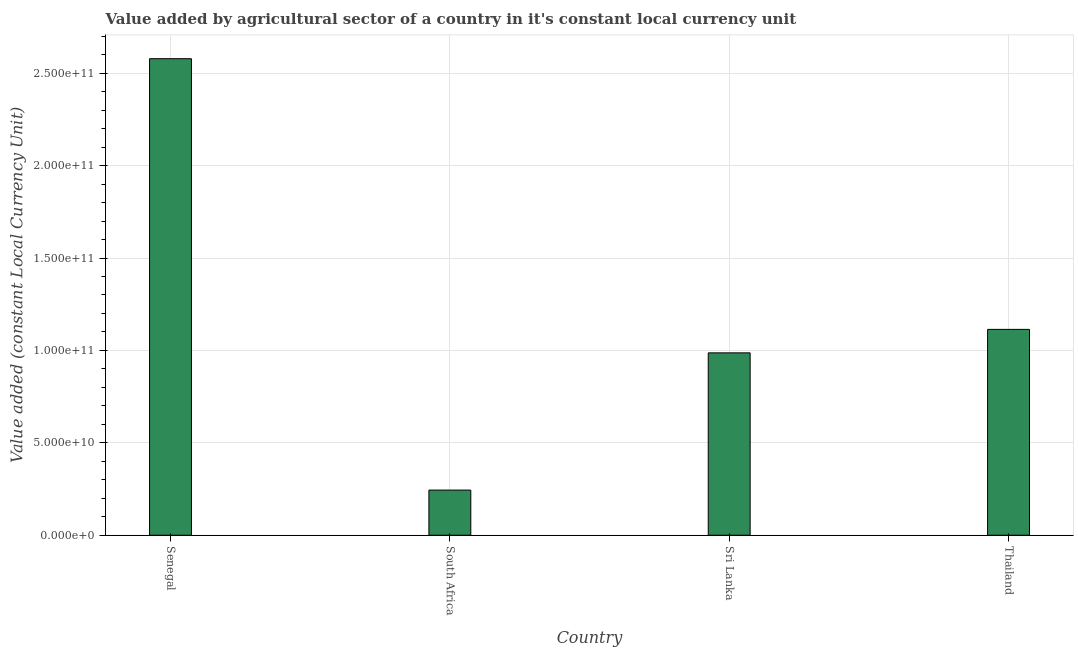Does the graph contain any zero values?
Provide a short and direct response. No. Does the graph contain grids?
Keep it short and to the point. Yes. What is the title of the graph?
Ensure brevity in your answer.  Value added by agricultural sector of a country in it's constant local currency unit. What is the label or title of the X-axis?
Your response must be concise. Country. What is the label or title of the Y-axis?
Give a very brief answer. Value added (constant Local Currency Unit). What is the value added by agriculture sector in Senegal?
Your answer should be compact. 2.58e+11. Across all countries, what is the maximum value added by agriculture sector?
Make the answer very short. 2.58e+11. Across all countries, what is the minimum value added by agriculture sector?
Ensure brevity in your answer.  2.44e+1. In which country was the value added by agriculture sector maximum?
Give a very brief answer. Senegal. In which country was the value added by agriculture sector minimum?
Give a very brief answer. South Africa. What is the sum of the value added by agriculture sector?
Give a very brief answer. 4.92e+11. What is the difference between the value added by agriculture sector in Senegal and Sri Lanka?
Your answer should be compact. 1.59e+11. What is the average value added by agriculture sector per country?
Your response must be concise. 1.23e+11. What is the median value added by agriculture sector?
Give a very brief answer. 1.05e+11. In how many countries, is the value added by agriculture sector greater than 10000000000 LCU?
Offer a very short reply. 4. What is the ratio of the value added by agriculture sector in Senegal to that in Thailand?
Make the answer very short. 2.31. Is the value added by agriculture sector in Senegal less than that in Thailand?
Give a very brief answer. No. What is the difference between the highest and the second highest value added by agriculture sector?
Offer a terse response. 1.46e+11. What is the difference between the highest and the lowest value added by agriculture sector?
Your answer should be very brief. 2.33e+11. In how many countries, is the value added by agriculture sector greater than the average value added by agriculture sector taken over all countries?
Make the answer very short. 1. Are all the bars in the graph horizontal?
Offer a terse response. No. Are the values on the major ticks of Y-axis written in scientific E-notation?
Offer a terse response. Yes. What is the Value added (constant Local Currency Unit) in Senegal?
Provide a succinct answer. 2.58e+11. What is the Value added (constant Local Currency Unit) in South Africa?
Your answer should be compact. 2.44e+1. What is the Value added (constant Local Currency Unit) of Sri Lanka?
Your answer should be very brief. 9.87e+1. What is the Value added (constant Local Currency Unit) in Thailand?
Your answer should be compact. 1.11e+11. What is the difference between the Value added (constant Local Currency Unit) in Senegal and South Africa?
Make the answer very short. 2.33e+11. What is the difference between the Value added (constant Local Currency Unit) in Senegal and Sri Lanka?
Make the answer very short. 1.59e+11. What is the difference between the Value added (constant Local Currency Unit) in Senegal and Thailand?
Make the answer very short. 1.46e+11. What is the difference between the Value added (constant Local Currency Unit) in South Africa and Sri Lanka?
Keep it short and to the point. -7.43e+1. What is the difference between the Value added (constant Local Currency Unit) in South Africa and Thailand?
Offer a very short reply. -8.70e+1. What is the difference between the Value added (constant Local Currency Unit) in Sri Lanka and Thailand?
Offer a terse response. -1.27e+1. What is the ratio of the Value added (constant Local Currency Unit) in Senegal to that in South Africa?
Provide a succinct answer. 10.55. What is the ratio of the Value added (constant Local Currency Unit) in Senegal to that in Sri Lanka?
Provide a succinct answer. 2.61. What is the ratio of the Value added (constant Local Currency Unit) in Senegal to that in Thailand?
Your response must be concise. 2.31. What is the ratio of the Value added (constant Local Currency Unit) in South Africa to that in Sri Lanka?
Your answer should be very brief. 0.25. What is the ratio of the Value added (constant Local Currency Unit) in South Africa to that in Thailand?
Keep it short and to the point. 0.22. What is the ratio of the Value added (constant Local Currency Unit) in Sri Lanka to that in Thailand?
Provide a succinct answer. 0.89. 